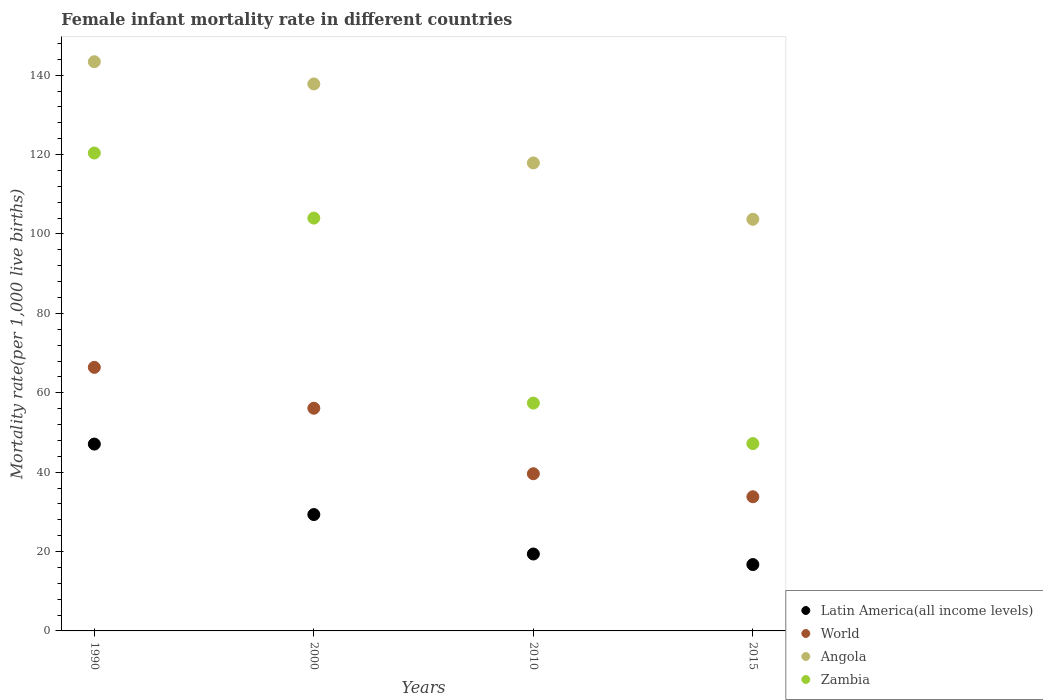How many different coloured dotlines are there?
Offer a terse response. 4. Is the number of dotlines equal to the number of legend labels?
Your answer should be compact. Yes. What is the female infant mortality rate in Latin America(all income levels) in 2010?
Give a very brief answer. 19.38. Across all years, what is the maximum female infant mortality rate in Zambia?
Your answer should be very brief. 120.4. Across all years, what is the minimum female infant mortality rate in Zambia?
Offer a terse response. 47.2. In which year was the female infant mortality rate in Zambia minimum?
Keep it short and to the point. 2015. What is the total female infant mortality rate in Angola in the graph?
Your answer should be compact. 502.8. What is the difference between the female infant mortality rate in Angola in 1990 and that in 2010?
Provide a short and direct response. 25.5. What is the difference between the female infant mortality rate in Latin America(all income levels) in 2000 and the female infant mortality rate in Angola in 2010?
Offer a terse response. -88.58. What is the average female infant mortality rate in Angola per year?
Provide a short and direct response. 125.7. In the year 2015, what is the difference between the female infant mortality rate in Latin America(all income levels) and female infant mortality rate in Zambia?
Offer a terse response. -30.48. In how many years, is the female infant mortality rate in Angola greater than 120?
Your answer should be compact. 2. What is the ratio of the female infant mortality rate in Latin America(all income levels) in 2000 to that in 2015?
Provide a succinct answer. 1.75. Is the female infant mortality rate in Latin America(all income levels) in 2000 less than that in 2015?
Give a very brief answer. No. Is the difference between the female infant mortality rate in Latin America(all income levels) in 1990 and 2000 greater than the difference between the female infant mortality rate in Zambia in 1990 and 2000?
Offer a very short reply. Yes. What is the difference between the highest and the second highest female infant mortality rate in Latin America(all income levels)?
Ensure brevity in your answer.  17.75. What is the difference between the highest and the lowest female infant mortality rate in Zambia?
Keep it short and to the point. 73.2. Is it the case that in every year, the sum of the female infant mortality rate in Latin America(all income levels) and female infant mortality rate in Angola  is greater than the female infant mortality rate in Zambia?
Your response must be concise. Yes. Is the female infant mortality rate in Zambia strictly less than the female infant mortality rate in Latin America(all income levels) over the years?
Offer a terse response. No. How many dotlines are there?
Offer a very short reply. 4. Does the graph contain any zero values?
Provide a short and direct response. No. How many legend labels are there?
Keep it short and to the point. 4. What is the title of the graph?
Your answer should be very brief. Female infant mortality rate in different countries. What is the label or title of the Y-axis?
Provide a short and direct response. Mortality rate(per 1,0 live births). What is the Mortality rate(per 1,000 live births) of Latin America(all income levels) in 1990?
Offer a very short reply. 47.07. What is the Mortality rate(per 1,000 live births) of World in 1990?
Give a very brief answer. 66.4. What is the Mortality rate(per 1,000 live births) of Angola in 1990?
Give a very brief answer. 143.4. What is the Mortality rate(per 1,000 live births) of Zambia in 1990?
Your answer should be very brief. 120.4. What is the Mortality rate(per 1,000 live births) in Latin America(all income levels) in 2000?
Offer a very short reply. 29.32. What is the Mortality rate(per 1,000 live births) of World in 2000?
Provide a succinct answer. 56.1. What is the Mortality rate(per 1,000 live births) in Angola in 2000?
Provide a succinct answer. 137.8. What is the Mortality rate(per 1,000 live births) in Zambia in 2000?
Keep it short and to the point. 104. What is the Mortality rate(per 1,000 live births) of Latin America(all income levels) in 2010?
Offer a terse response. 19.38. What is the Mortality rate(per 1,000 live births) of World in 2010?
Your answer should be very brief. 39.6. What is the Mortality rate(per 1,000 live births) of Angola in 2010?
Offer a very short reply. 117.9. What is the Mortality rate(per 1,000 live births) in Zambia in 2010?
Make the answer very short. 57.4. What is the Mortality rate(per 1,000 live births) in Latin America(all income levels) in 2015?
Offer a very short reply. 16.72. What is the Mortality rate(per 1,000 live births) of World in 2015?
Your response must be concise. 33.8. What is the Mortality rate(per 1,000 live births) in Angola in 2015?
Your answer should be compact. 103.7. What is the Mortality rate(per 1,000 live births) of Zambia in 2015?
Your response must be concise. 47.2. Across all years, what is the maximum Mortality rate(per 1,000 live births) of Latin America(all income levels)?
Your answer should be very brief. 47.07. Across all years, what is the maximum Mortality rate(per 1,000 live births) in World?
Make the answer very short. 66.4. Across all years, what is the maximum Mortality rate(per 1,000 live births) of Angola?
Make the answer very short. 143.4. Across all years, what is the maximum Mortality rate(per 1,000 live births) of Zambia?
Offer a terse response. 120.4. Across all years, what is the minimum Mortality rate(per 1,000 live births) in Latin America(all income levels)?
Give a very brief answer. 16.72. Across all years, what is the minimum Mortality rate(per 1,000 live births) of World?
Your response must be concise. 33.8. Across all years, what is the minimum Mortality rate(per 1,000 live births) in Angola?
Offer a terse response. 103.7. Across all years, what is the minimum Mortality rate(per 1,000 live births) of Zambia?
Keep it short and to the point. 47.2. What is the total Mortality rate(per 1,000 live births) in Latin America(all income levels) in the graph?
Offer a very short reply. 112.49. What is the total Mortality rate(per 1,000 live births) in World in the graph?
Offer a very short reply. 195.9. What is the total Mortality rate(per 1,000 live births) of Angola in the graph?
Your response must be concise. 502.8. What is the total Mortality rate(per 1,000 live births) in Zambia in the graph?
Keep it short and to the point. 329. What is the difference between the Mortality rate(per 1,000 live births) in Latin America(all income levels) in 1990 and that in 2000?
Give a very brief answer. 17.75. What is the difference between the Mortality rate(per 1,000 live births) in Angola in 1990 and that in 2000?
Offer a very short reply. 5.6. What is the difference between the Mortality rate(per 1,000 live births) in Latin America(all income levels) in 1990 and that in 2010?
Offer a terse response. 27.69. What is the difference between the Mortality rate(per 1,000 live births) in World in 1990 and that in 2010?
Offer a terse response. 26.8. What is the difference between the Mortality rate(per 1,000 live births) of Angola in 1990 and that in 2010?
Keep it short and to the point. 25.5. What is the difference between the Mortality rate(per 1,000 live births) of Latin America(all income levels) in 1990 and that in 2015?
Your answer should be compact. 30.35. What is the difference between the Mortality rate(per 1,000 live births) in World in 1990 and that in 2015?
Ensure brevity in your answer.  32.6. What is the difference between the Mortality rate(per 1,000 live births) of Angola in 1990 and that in 2015?
Provide a succinct answer. 39.7. What is the difference between the Mortality rate(per 1,000 live births) of Zambia in 1990 and that in 2015?
Provide a succinct answer. 73.2. What is the difference between the Mortality rate(per 1,000 live births) of Latin America(all income levels) in 2000 and that in 2010?
Keep it short and to the point. 9.94. What is the difference between the Mortality rate(per 1,000 live births) of World in 2000 and that in 2010?
Offer a very short reply. 16.5. What is the difference between the Mortality rate(per 1,000 live births) in Angola in 2000 and that in 2010?
Ensure brevity in your answer.  19.9. What is the difference between the Mortality rate(per 1,000 live births) in Zambia in 2000 and that in 2010?
Provide a succinct answer. 46.6. What is the difference between the Mortality rate(per 1,000 live births) of Latin America(all income levels) in 2000 and that in 2015?
Provide a short and direct response. 12.6. What is the difference between the Mortality rate(per 1,000 live births) in World in 2000 and that in 2015?
Your answer should be compact. 22.3. What is the difference between the Mortality rate(per 1,000 live births) in Angola in 2000 and that in 2015?
Provide a succinct answer. 34.1. What is the difference between the Mortality rate(per 1,000 live births) of Zambia in 2000 and that in 2015?
Make the answer very short. 56.8. What is the difference between the Mortality rate(per 1,000 live births) in Latin America(all income levels) in 2010 and that in 2015?
Offer a terse response. 2.66. What is the difference between the Mortality rate(per 1,000 live births) in Angola in 2010 and that in 2015?
Provide a succinct answer. 14.2. What is the difference between the Mortality rate(per 1,000 live births) of Latin America(all income levels) in 1990 and the Mortality rate(per 1,000 live births) of World in 2000?
Offer a terse response. -9.03. What is the difference between the Mortality rate(per 1,000 live births) in Latin America(all income levels) in 1990 and the Mortality rate(per 1,000 live births) in Angola in 2000?
Offer a terse response. -90.73. What is the difference between the Mortality rate(per 1,000 live births) in Latin America(all income levels) in 1990 and the Mortality rate(per 1,000 live births) in Zambia in 2000?
Make the answer very short. -56.93. What is the difference between the Mortality rate(per 1,000 live births) in World in 1990 and the Mortality rate(per 1,000 live births) in Angola in 2000?
Your answer should be very brief. -71.4. What is the difference between the Mortality rate(per 1,000 live births) in World in 1990 and the Mortality rate(per 1,000 live births) in Zambia in 2000?
Keep it short and to the point. -37.6. What is the difference between the Mortality rate(per 1,000 live births) in Angola in 1990 and the Mortality rate(per 1,000 live births) in Zambia in 2000?
Keep it short and to the point. 39.4. What is the difference between the Mortality rate(per 1,000 live births) of Latin America(all income levels) in 1990 and the Mortality rate(per 1,000 live births) of World in 2010?
Your response must be concise. 7.47. What is the difference between the Mortality rate(per 1,000 live births) in Latin America(all income levels) in 1990 and the Mortality rate(per 1,000 live births) in Angola in 2010?
Offer a terse response. -70.83. What is the difference between the Mortality rate(per 1,000 live births) in Latin America(all income levels) in 1990 and the Mortality rate(per 1,000 live births) in Zambia in 2010?
Give a very brief answer. -10.33. What is the difference between the Mortality rate(per 1,000 live births) of World in 1990 and the Mortality rate(per 1,000 live births) of Angola in 2010?
Your answer should be compact. -51.5. What is the difference between the Mortality rate(per 1,000 live births) in World in 1990 and the Mortality rate(per 1,000 live births) in Zambia in 2010?
Provide a succinct answer. 9. What is the difference between the Mortality rate(per 1,000 live births) in Angola in 1990 and the Mortality rate(per 1,000 live births) in Zambia in 2010?
Provide a short and direct response. 86. What is the difference between the Mortality rate(per 1,000 live births) in Latin America(all income levels) in 1990 and the Mortality rate(per 1,000 live births) in World in 2015?
Provide a succinct answer. 13.27. What is the difference between the Mortality rate(per 1,000 live births) in Latin America(all income levels) in 1990 and the Mortality rate(per 1,000 live births) in Angola in 2015?
Offer a terse response. -56.63. What is the difference between the Mortality rate(per 1,000 live births) in Latin America(all income levels) in 1990 and the Mortality rate(per 1,000 live births) in Zambia in 2015?
Make the answer very short. -0.13. What is the difference between the Mortality rate(per 1,000 live births) in World in 1990 and the Mortality rate(per 1,000 live births) in Angola in 2015?
Offer a terse response. -37.3. What is the difference between the Mortality rate(per 1,000 live births) in World in 1990 and the Mortality rate(per 1,000 live births) in Zambia in 2015?
Your answer should be compact. 19.2. What is the difference between the Mortality rate(per 1,000 live births) in Angola in 1990 and the Mortality rate(per 1,000 live births) in Zambia in 2015?
Offer a very short reply. 96.2. What is the difference between the Mortality rate(per 1,000 live births) in Latin America(all income levels) in 2000 and the Mortality rate(per 1,000 live births) in World in 2010?
Provide a short and direct response. -10.28. What is the difference between the Mortality rate(per 1,000 live births) of Latin America(all income levels) in 2000 and the Mortality rate(per 1,000 live births) of Angola in 2010?
Your answer should be compact. -88.58. What is the difference between the Mortality rate(per 1,000 live births) of Latin America(all income levels) in 2000 and the Mortality rate(per 1,000 live births) of Zambia in 2010?
Your response must be concise. -28.08. What is the difference between the Mortality rate(per 1,000 live births) of World in 2000 and the Mortality rate(per 1,000 live births) of Angola in 2010?
Make the answer very short. -61.8. What is the difference between the Mortality rate(per 1,000 live births) of World in 2000 and the Mortality rate(per 1,000 live births) of Zambia in 2010?
Make the answer very short. -1.3. What is the difference between the Mortality rate(per 1,000 live births) in Angola in 2000 and the Mortality rate(per 1,000 live births) in Zambia in 2010?
Give a very brief answer. 80.4. What is the difference between the Mortality rate(per 1,000 live births) in Latin America(all income levels) in 2000 and the Mortality rate(per 1,000 live births) in World in 2015?
Provide a succinct answer. -4.48. What is the difference between the Mortality rate(per 1,000 live births) of Latin America(all income levels) in 2000 and the Mortality rate(per 1,000 live births) of Angola in 2015?
Offer a terse response. -74.38. What is the difference between the Mortality rate(per 1,000 live births) in Latin America(all income levels) in 2000 and the Mortality rate(per 1,000 live births) in Zambia in 2015?
Offer a terse response. -17.88. What is the difference between the Mortality rate(per 1,000 live births) in World in 2000 and the Mortality rate(per 1,000 live births) in Angola in 2015?
Provide a short and direct response. -47.6. What is the difference between the Mortality rate(per 1,000 live births) in Angola in 2000 and the Mortality rate(per 1,000 live births) in Zambia in 2015?
Offer a terse response. 90.6. What is the difference between the Mortality rate(per 1,000 live births) of Latin America(all income levels) in 2010 and the Mortality rate(per 1,000 live births) of World in 2015?
Offer a very short reply. -14.42. What is the difference between the Mortality rate(per 1,000 live births) of Latin America(all income levels) in 2010 and the Mortality rate(per 1,000 live births) of Angola in 2015?
Provide a short and direct response. -84.32. What is the difference between the Mortality rate(per 1,000 live births) of Latin America(all income levels) in 2010 and the Mortality rate(per 1,000 live births) of Zambia in 2015?
Your answer should be compact. -27.82. What is the difference between the Mortality rate(per 1,000 live births) in World in 2010 and the Mortality rate(per 1,000 live births) in Angola in 2015?
Make the answer very short. -64.1. What is the difference between the Mortality rate(per 1,000 live births) of World in 2010 and the Mortality rate(per 1,000 live births) of Zambia in 2015?
Your answer should be compact. -7.6. What is the difference between the Mortality rate(per 1,000 live births) in Angola in 2010 and the Mortality rate(per 1,000 live births) in Zambia in 2015?
Make the answer very short. 70.7. What is the average Mortality rate(per 1,000 live births) in Latin America(all income levels) per year?
Provide a short and direct response. 28.12. What is the average Mortality rate(per 1,000 live births) in World per year?
Offer a very short reply. 48.98. What is the average Mortality rate(per 1,000 live births) in Angola per year?
Keep it short and to the point. 125.7. What is the average Mortality rate(per 1,000 live births) in Zambia per year?
Provide a short and direct response. 82.25. In the year 1990, what is the difference between the Mortality rate(per 1,000 live births) in Latin America(all income levels) and Mortality rate(per 1,000 live births) in World?
Offer a terse response. -19.33. In the year 1990, what is the difference between the Mortality rate(per 1,000 live births) of Latin America(all income levels) and Mortality rate(per 1,000 live births) of Angola?
Your answer should be very brief. -96.33. In the year 1990, what is the difference between the Mortality rate(per 1,000 live births) in Latin America(all income levels) and Mortality rate(per 1,000 live births) in Zambia?
Your response must be concise. -73.33. In the year 1990, what is the difference between the Mortality rate(per 1,000 live births) of World and Mortality rate(per 1,000 live births) of Angola?
Your answer should be compact. -77. In the year 1990, what is the difference between the Mortality rate(per 1,000 live births) of World and Mortality rate(per 1,000 live births) of Zambia?
Your response must be concise. -54. In the year 1990, what is the difference between the Mortality rate(per 1,000 live births) in Angola and Mortality rate(per 1,000 live births) in Zambia?
Provide a succinct answer. 23. In the year 2000, what is the difference between the Mortality rate(per 1,000 live births) of Latin America(all income levels) and Mortality rate(per 1,000 live births) of World?
Offer a terse response. -26.78. In the year 2000, what is the difference between the Mortality rate(per 1,000 live births) of Latin America(all income levels) and Mortality rate(per 1,000 live births) of Angola?
Make the answer very short. -108.48. In the year 2000, what is the difference between the Mortality rate(per 1,000 live births) in Latin America(all income levels) and Mortality rate(per 1,000 live births) in Zambia?
Your answer should be very brief. -74.68. In the year 2000, what is the difference between the Mortality rate(per 1,000 live births) of World and Mortality rate(per 1,000 live births) of Angola?
Your answer should be compact. -81.7. In the year 2000, what is the difference between the Mortality rate(per 1,000 live births) in World and Mortality rate(per 1,000 live births) in Zambia?
Provide a short and direct response. -47.9. In the year 2000, what is the difference between the Mortality rate(per 1,000 live births) of Angola and Mortality rate(per 1,000 live births) of Zambia?
Your answer should be compact. 33.8. In the year 2010, what is the difference between the Mortality rate(per 1,000 live births) of Latin America(all income levels) and Mortality rate(per 1,000 live births) of World?
Your answer should be compact. -20.22. In the year 2010, what is the difference between the Mortality rate(per 1,000 live births) of Latin America(all income levels) and Mortality rate(per 1,000 live births) of Angola?
Your answer should be very brief. -98.52. In the year 2010, what is the difference between the Mortality rate(per 1,000 live births) in Latin America(all income levels) and Mortality rate(per 1,000 live births) in Zambia?
Give a very brief answer. -38.02. In the year 2010, what is the difference between the Mortality rate(per 1,000 live births) in World and Mortality rate(per 1,000 live births) in Angola?
Your answer should be compact. -78.3. In the year 2010, what is the difference between the Mortality rate(per 1,000 live births) of World and Mortality rate(per 1,000 live births) of Zambia?
Provide a succinct answer. -17.8. In the year 2010, what is the difference between the Mortality rate(per 1,000 live births) in Angola and Mortality rate(per 1,000 live births) in Zambia?
Provide a short and direct response. 60.5. In the year 2015, what is the difference between the Mortality rate(per 1,000 live births) in Latin America(all income levels) and Mortality rate(per 1,000 live births) in World?
Your response must be concise. -17.08. In the year 2015, what is the difference between the Mortality rate(per 1,000 live births) of Latin America(all income levels) and Mortality rate(per 1,000 live births) of Angola?
Provide a short and direct response. -86.98. In the year 2015, what is the difference between the Mortality rate(per 1,000 live births) of Latin America(all income levels) and Mortality rate(per 1,000 live births) of Zambia?
Your answer should be very brief. -30.48. In the year 2015, what is the difference between the Mortality rate(per 1,000 live births) of World and Mortality rate(per 1,000 live births) of Angola?
Offer a terse response. -69.9. In the year 2015, what is the difference between the Mortality rate(per 1,000 live births) in Angola and Mortality rate(per 1,000 live births) in Zambia?
Your response must be concise. 56.5. What is the ratio of the Mortality rate(per 1,000 live births) of Latin America(all income levels) in 1990 to that in 2000?
Ensure brevity in your answer.  1.61. What is the ratio of the Mortality rate(per 1,000 live births) of World in 1990 to that in 2000?
Offer a terse response. 1.18. What is the ratio of the Mortality rate(per 1,000 live births) in Angola in 1990 to that in 2000?
Your answer should be compact. 1.04. What is the ratio of the Mortality rate(per 1,000 live births) of Zambia in 1990 to that in 2000?
Your answer should be very brief. 1.16. What is the ratio of the Mortality rate(per 1,000 live births) in Latin America(all income levels) in 1990 to that in 2010?
Offer a terse response. 2.43. What is the ratio of the Mortality rate(per 1,000 live births) of World in 1990 to that in 2010?
Your response must be concise. 1.68. What is the ratio of the Mortality rate(per 1,000 live births) in Angola in 1990 to that in 2010?
Give a very brief answer. 1.22. What is the ratio of the Mortality rate(per 1,000 live births) in Zambia in 1990 to that in 2010?
Your answer should be compact. 2.1. What is the ratio of the Mortality rate(per 1,000 live births) in Latin America(all income levels) in 1990 to that in 2015?
Your response must be concise. 2.82. What is the ratio of the Mortality rate(per 1,000 live births) of World in 1990 to that in 2015?
Your answer should be compact. 1.96. What is the ratio of the Mortality rate(per 1,000 live births) in Angola in 1990 to that in 2015?
Your response must be concise. 1.38. What is the ratio of the Mortality rate(per 1,000 live births) of Zambia in 1990 to that in 2015?
Offer a terse response. 2.55. What is the ratio of the Mortality rate(per 1,000 live births) in Latin America(all income levels) in 2000 to that in 2010?
Ensure brevity in your answer.  1.51. What is the ratio of the Mortality rate(per 1,000 live births) in World in 2000 to that in 2010?
Your response must be concise. 1.42. What is the ratio of the Mortality rate(per 1,000 live births) of Angola in 2000 to that in 2010?
Your answer should be very brief. 1.17. What is the ratio of the Mortality rate(per 1,000 live births) of Zambia in 2000 to that in 2010?
Your response must be concise. 1.81. What is the ratio of the Mortality rate(per 1,000 live births) in Latin America(all income levels) in 2000 to that in 2015?
Offer a terse response. 1.75. What is the ratio of the Mortality rate(per 1,000 live births) of World in 2000 to that in 2015?
Your response must be concise. 1.66. What is the ratio of the Mortality rate(per 1,000 live births) in Angola in 2000 to that in 2015?
Your answer should be compact. 1.33. What is the ratio of the Mortality rate(per 1,000 live births) in Zambia in 2000 to that in 2015?
Ensure brevity in your answer.  2.2. What is the ratio of the Mortality rate(per 1,000 live births) in Latin America(all income levels) in 2010 to that in 2015?
Give a very brief answer. 1.16. What is the ratio of the Mortality rate(per 1,000 live births) in World in 2010 to that in 2015?
Provide a succinct answer. 1.17. What is the ratio of the Mortality rate(per 1,000 live births) in Angola in 2010 to that in 2015?
Provide a short and direct response. 1.14. What is the ratio of the Mortality rate(per 1,000 live births) in Zambia in 2010 to that in 2015?
Your answer should be compact. 1.22. What is the difference between the highest and the second highest Mortality rate(per 1,000 live births) in Latin America(all income levels)?
Offer a terse response. 17.75. What is the difference between the highest and the second highest Mortality rate(per 1,000 live births) in World?
Offer a very short reply. 10.3. What is the difference between the highest and the second highest Mortality rate(per 1,000 live births) of Angola?
Give a very brief answer. 5.6. What is the difference between the highest and the lowest Mortality rate(per 1,000 live births) of Latin America(all income levels)?
Keep it short and to the point. 30.35. What is the difference between the highest and the lowest Mortality rate(per 1,000 live births) in World?
Your response must be concise. 32.6. What is the difference between the highest and the lowest Mortality rate(per 1,000 live births) of Angola?
Offer a terse response. 39.7. What is the difference between the highest and the lowest Mortality rate(per 1,000 live births) of Zambia?
Your answer should be compact. 73.2. 